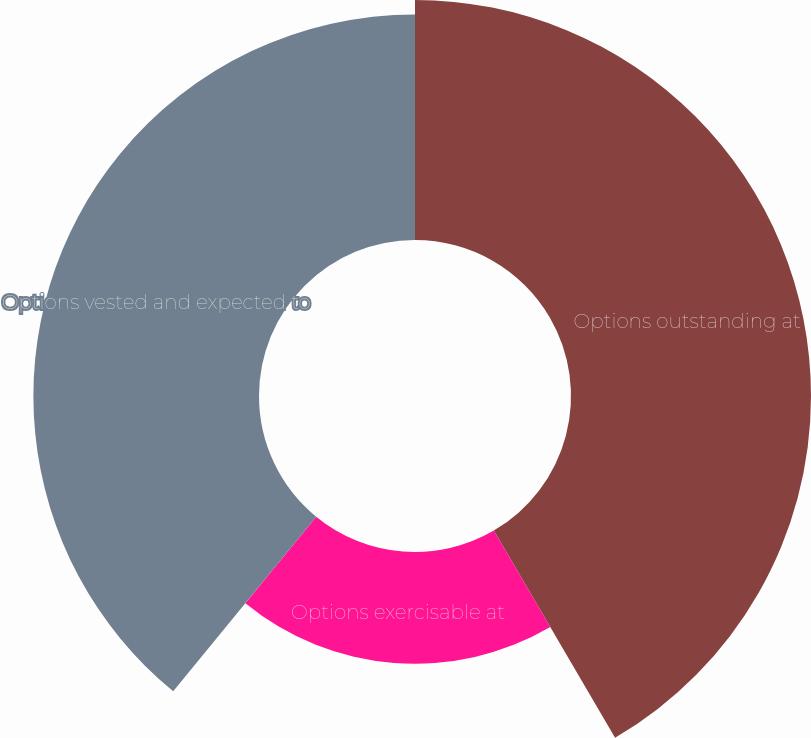Convert chart. <chart><loc_0><loc_0><loc_500><loc_500><pie_chart><fcel>Options outstanding at<fcel>Options exercisable at<fcel>Options vested and expected to<nl><fcel>41.57%<fcel>19.35%<fcel>39.08%<nl></chart> 